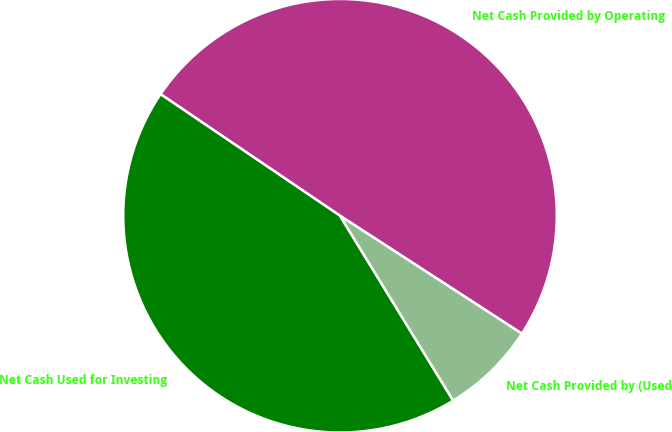Convert chart to OTSL. <chart><loc_0><loc_0><loc_500><loc_500><pie_chart><fcel>Net Cash Provided by Operating<fcel>Net Cash Used for Investing<fcel>Net Cash Provided by (Used<nl><fcel>49.68%<fcel>43.22%<fcel>7.1%<nl></chart> 